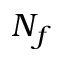Convert formula to latex. <formula><loc_0><loc_0><loc_500><loc_500>N _ { f }</formula> 